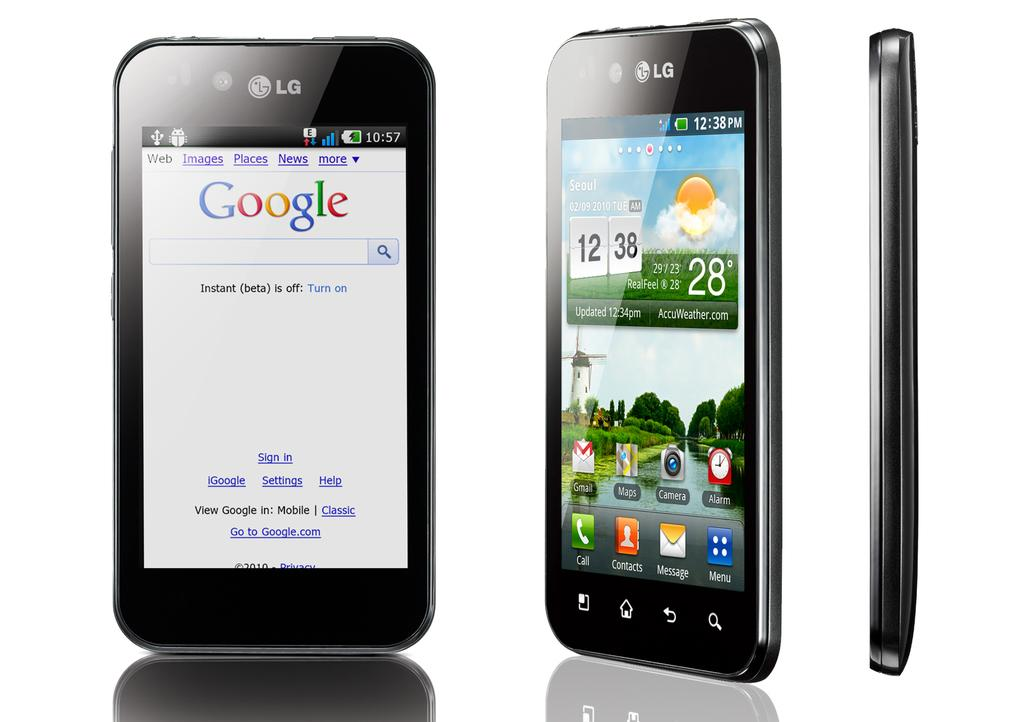<image>
Render a clear and concise summary of the photo. A black LG smartphone from three different angles. 